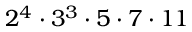<formula> <loc_0><loc_0><loc_500><loc_500>2 ^ { 4 } \cdot 3 ^ { 3 } \cdot 5 \cdot 7 \cdot 1 1</formula> 